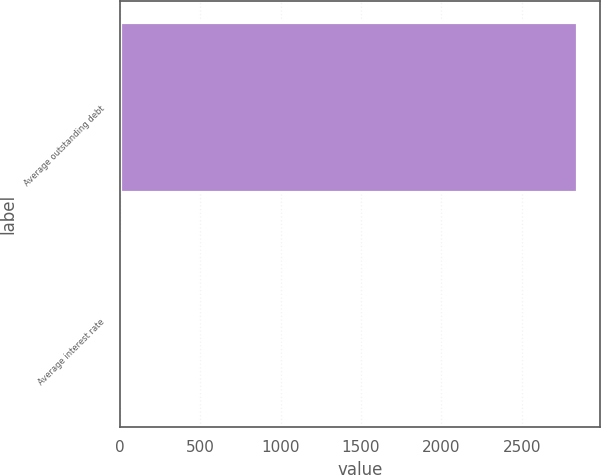Convert chart to OTSL. <chart><loc_0><loc_0><loc_500><loc_500><bar_chart><fcel>Average outstanding debt<fcel>Average interest rate<nl><fcel>2843.7<fcel>4.9<nl></chart> 